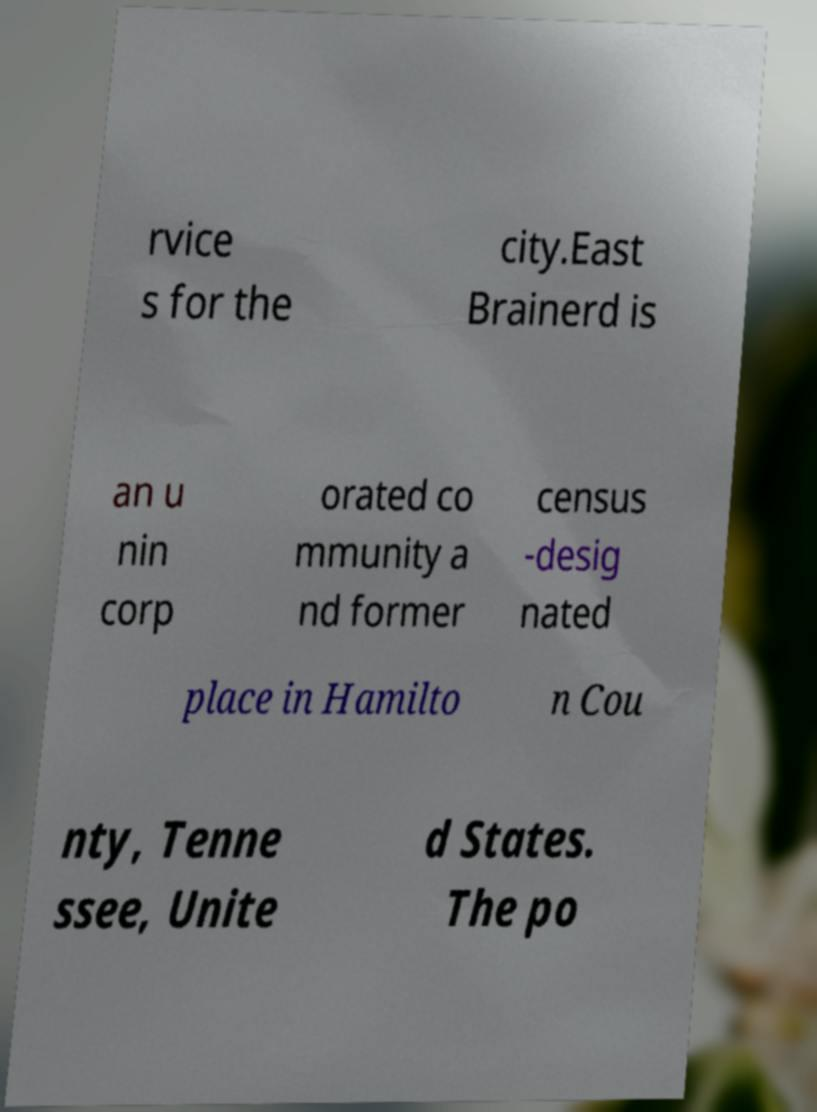I need the written content from this picture converted into text. Can you do that? rvice s for the city.East Brainerd is an u nin corp orated co mmunity a nd former census -desig nated place in Hamilto n Cou nty, Tenne ssee, Unite d States. The po 